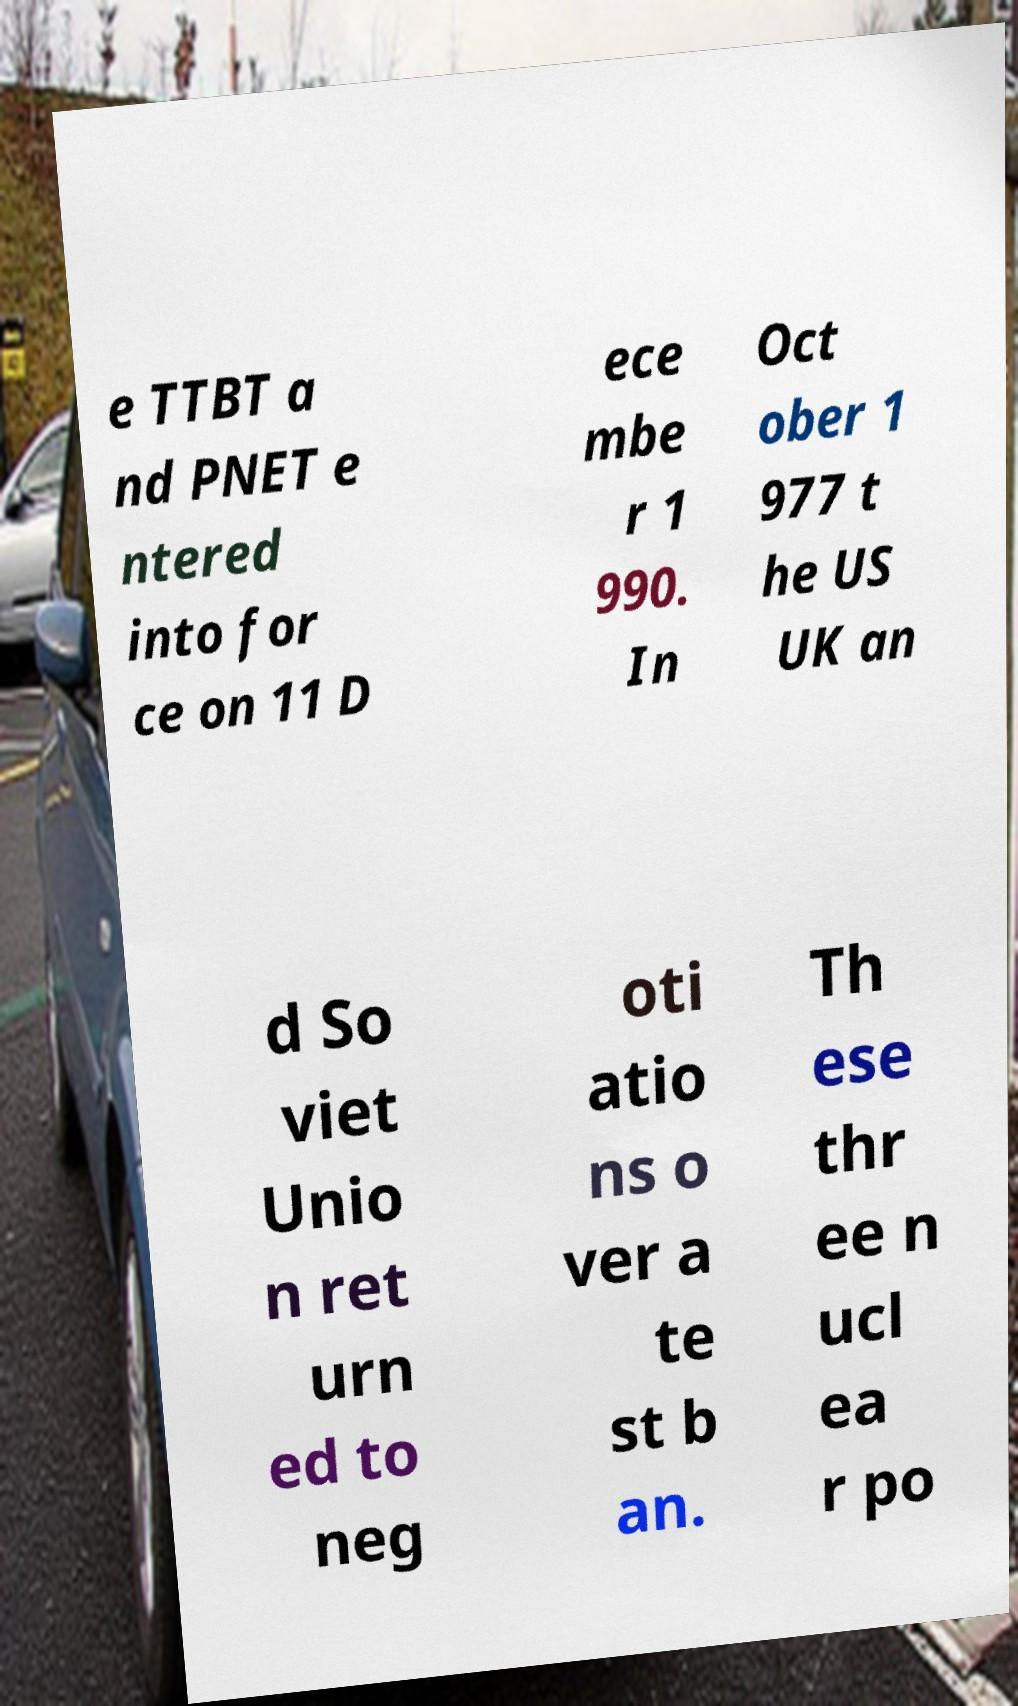Could you assist in decoding the text presented in this image and type it out clearly? e TTBT a nd PNET e ntered into for ce on 11 D ece mbe r 1 990. In Oct ober 1 977 t he US UK an d So viet Unio n ret urn ed to neg oti atio ns o ver a te st b an. Th ese thr ee n ucl ea r po 